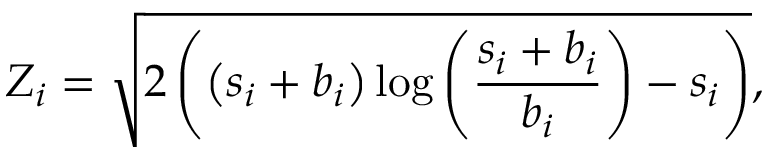Convert formula to latex. <formula><loc_0><loc_0><loc_500><loc_500>Z _ { i } = \sqrt { 2 \left ( \left ( s _ { i } + b _ { i } \right ) \log \left ( \frac { s _ { i } + b _ { i } } { b _ { i } } \right ) - s _ { i } \right ) } ,</formula> 